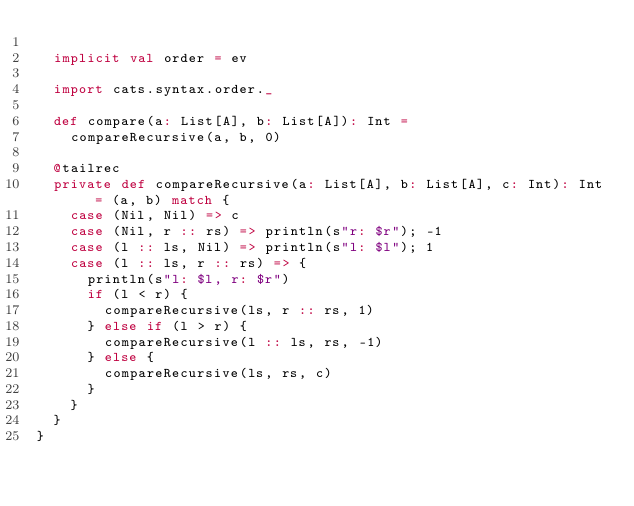<code> <loc_0><loc_0><loc_500><loc_500><_Scala_>
  implicit val order = ev

  import cats.syntax.order._

  def compare(a: List[A], b: List[A]): Int =
    compareRecursive(a, b, 0)

  @tailrec
  private def compareRecursive(a: List[A], b: List[A], c: Int): Int = (a, b) match {
    case (Nil, Nil) => c
    case (Nil, r :: rs) => println(s"r: $r"); -1
    case (l :: ls, Nil) => println(s"l: $l"); 1
    case (l :: ls, r :: rs) => {
      println(s"l: $l, r: $r")
      if (l < r) {
        compareRecursive(ls, r :: rs, 1)
      } else if (l > r) {
        compareRecursive(l :: ls, rs, -1)
      } else {
        compareRecursive(ls, rs, c)
      }
    }
  }
}
</code> 